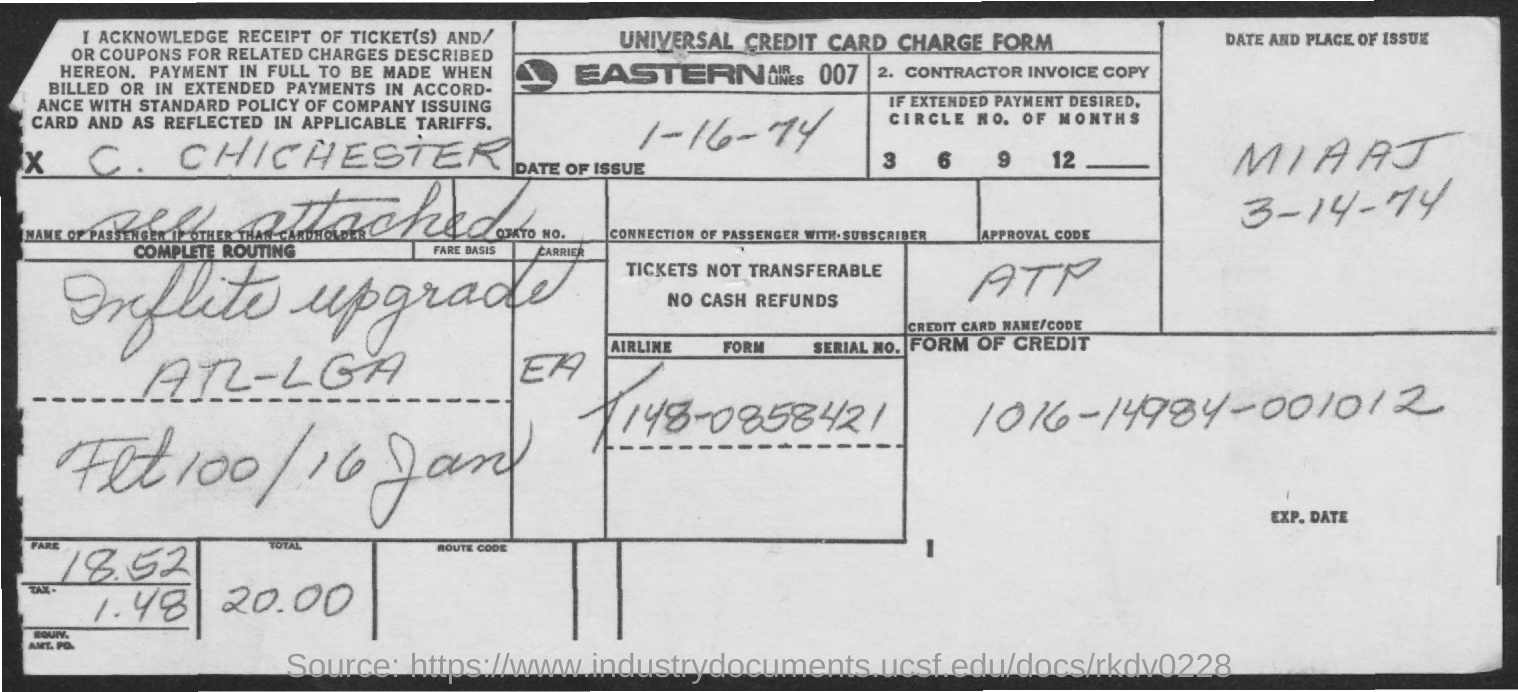What is the title of the given document?
Your response must be concise. Universal credit card charge form. What is the name of the airlines mentioned?
Provide a succinct answer. Eastern airlines. What is the total fare?
Your answer should be compact. 20.00. What is the form of credit?
Your response must be concise. 1016-14984-001012. 